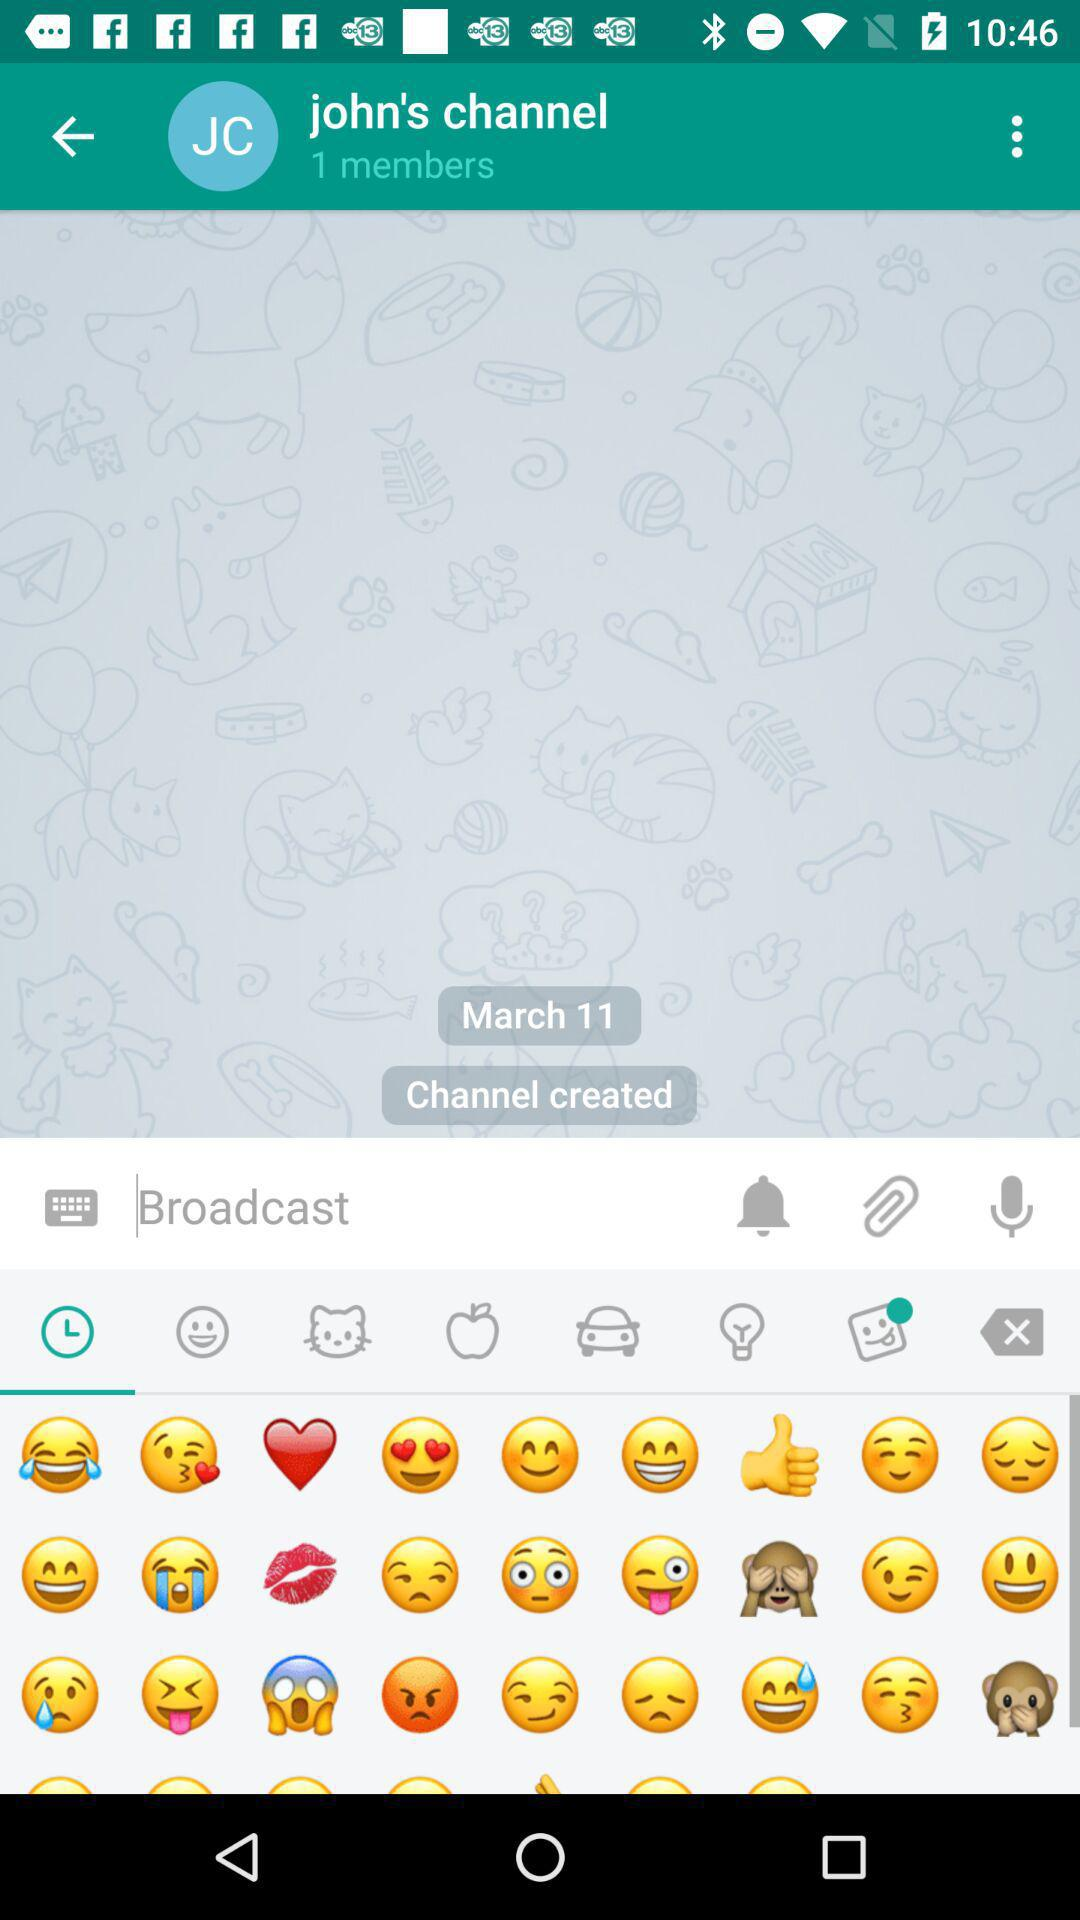When was channel created? The channel was created on March 11. 